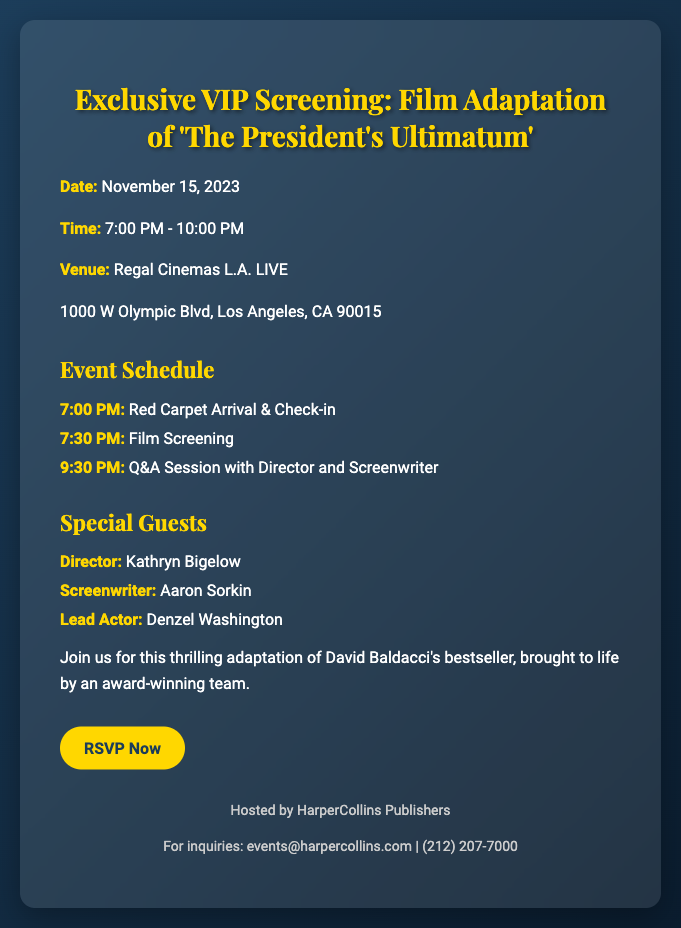What is the date of the event? The date of the event is specified in the document.
Answer: November 15, 2023 What time does the film screening start? The time for the film screening is provided in the event schedule.
Answer: 7:30 PM Who is the lead actor in the film? The lead actor is listed under the special guests section.
Answer: Denzel Washington What is the venue for the screening? The venue is mentioned at the beginning of the card.
Answer: Regal Cinemas L.A. LIVE What is the duration of the event? The event runs from 7:00 PM to 10:00 PM, which can be calculated.
Answer: 3 hours Who will be hosting the event? The hosting information is included at the bottom of the document.
Answer: HarperCollins Publishers What is the title of the film being screened? The title is stated in the main heading of the card.
Answer: The President's Ultimatum When does the Q&A session begin? The timing for the Q&A session is provided in the event schedule.
Answer: 9:30 PM What type of event is this? The RSVP card indicates the nature of the event.
Answer: VIP Screening 